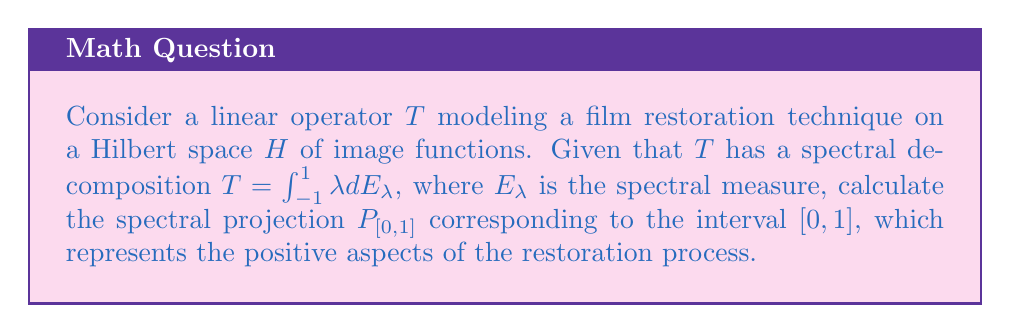Solve this math problem. To solve for the spectral projection $P_{[0,1]}$, we follow these steps:

1) The spectral projection $P_{[0,1]}$ is defined as the integral of the spectral measure over the interval $[0,1]$:

   $$P_{[0,1]} = \int_{[0,1]} dE_\lambda$$

2) Given the spectral decomposition of $T$, we know that the spectral measure $E_\lambda$ is supported on $[-1,1]$.

3) The spectral projection $P_{[0,1]}$ represents the part of the operator $T$ that corresponds to the positive eigenvalues in $[0,1]$, which can be interpreted as the beneficial aspects of the restoration process.

4) To calculate this projection, we need to integrate the spectral measure over $[0,1]$:

   $$P_{[0,1]} = E(1) - E(0)$$

   Where $E(\lambda)$ is the right-continuous spectral family associated with $T$.

5) In the context of film restoration, this projection would isolate the components of the restoration process that enhance the image quality without introducing distortions (which would be represented by negative eigenvalues).

6) The resulting projection $P_{[0,1]}$ is an orthogonal projection onto the subspace of $H$ corresponding to the positive aspects of the restoration technique.
Answer: $P_{[0,1]} = E(1) - E(0)$ 